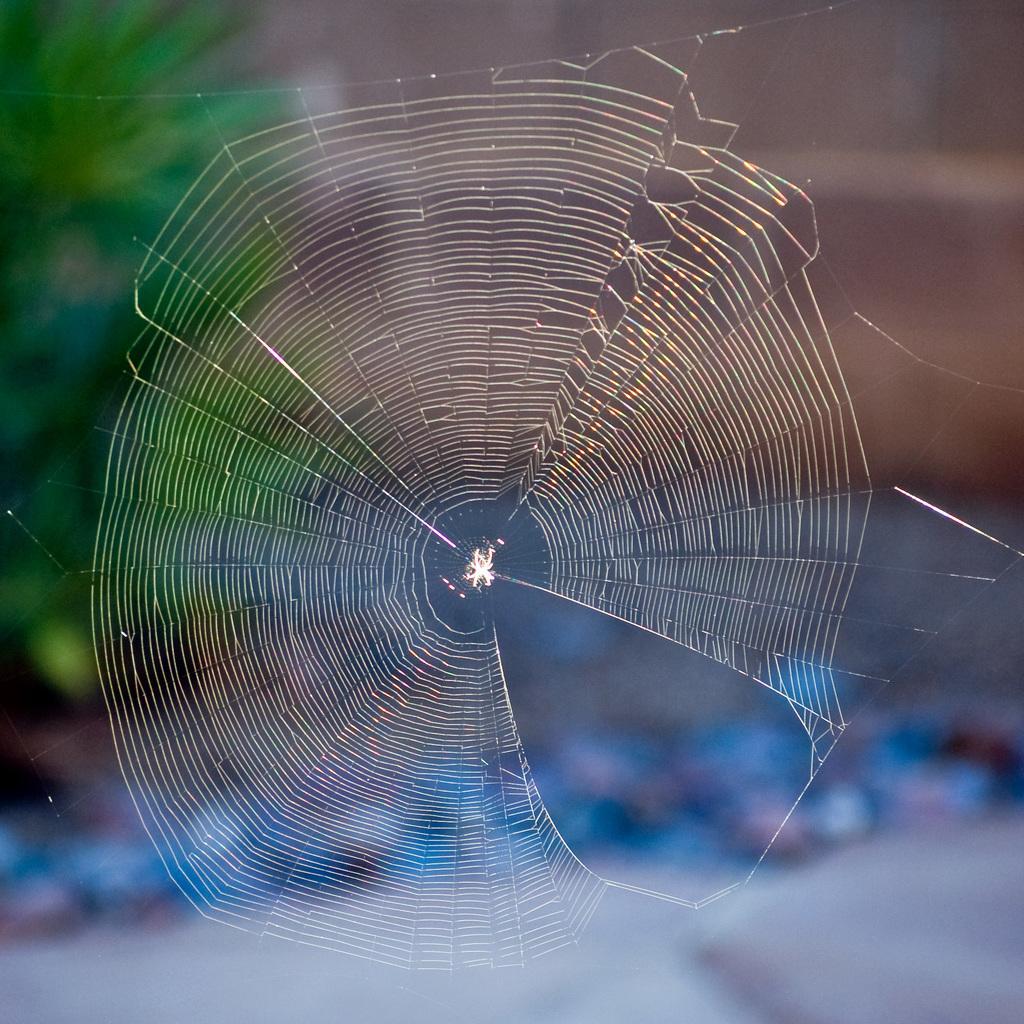Please provide a concise description of this image. In this image we can see a spider and a spider web with blur background. 